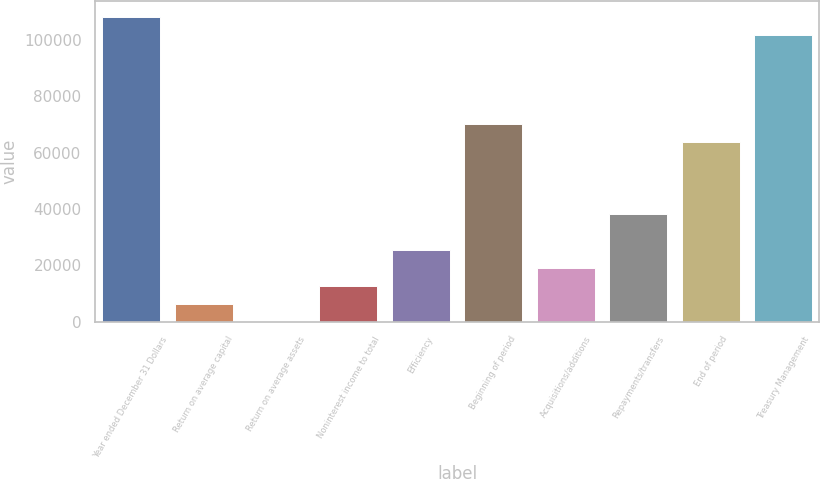Convert chart to OTSL. <chart><loc_0><loc_0><loc_500><loc_500><bar_chart><fcel>Year ended December 31 Dollars<fcel>Return on average capital<fcel>Return on average assets<fcel>Noninterest income to total<fcel>Efficiency<fcel>Beginning of period<fcel>Acquisitions/additions<fcel>Repayments/transfers<fcel>End of period<fcel>Treasury Management<nl><fcel>108280<fcel>6371.58<fcel>2.31<fcel>12740.9<fcel>25479.4<fcel>70064.3<fcel>19110.1<fcel>38217.9<fcel>63695<fcel>101911<nl></chart> 